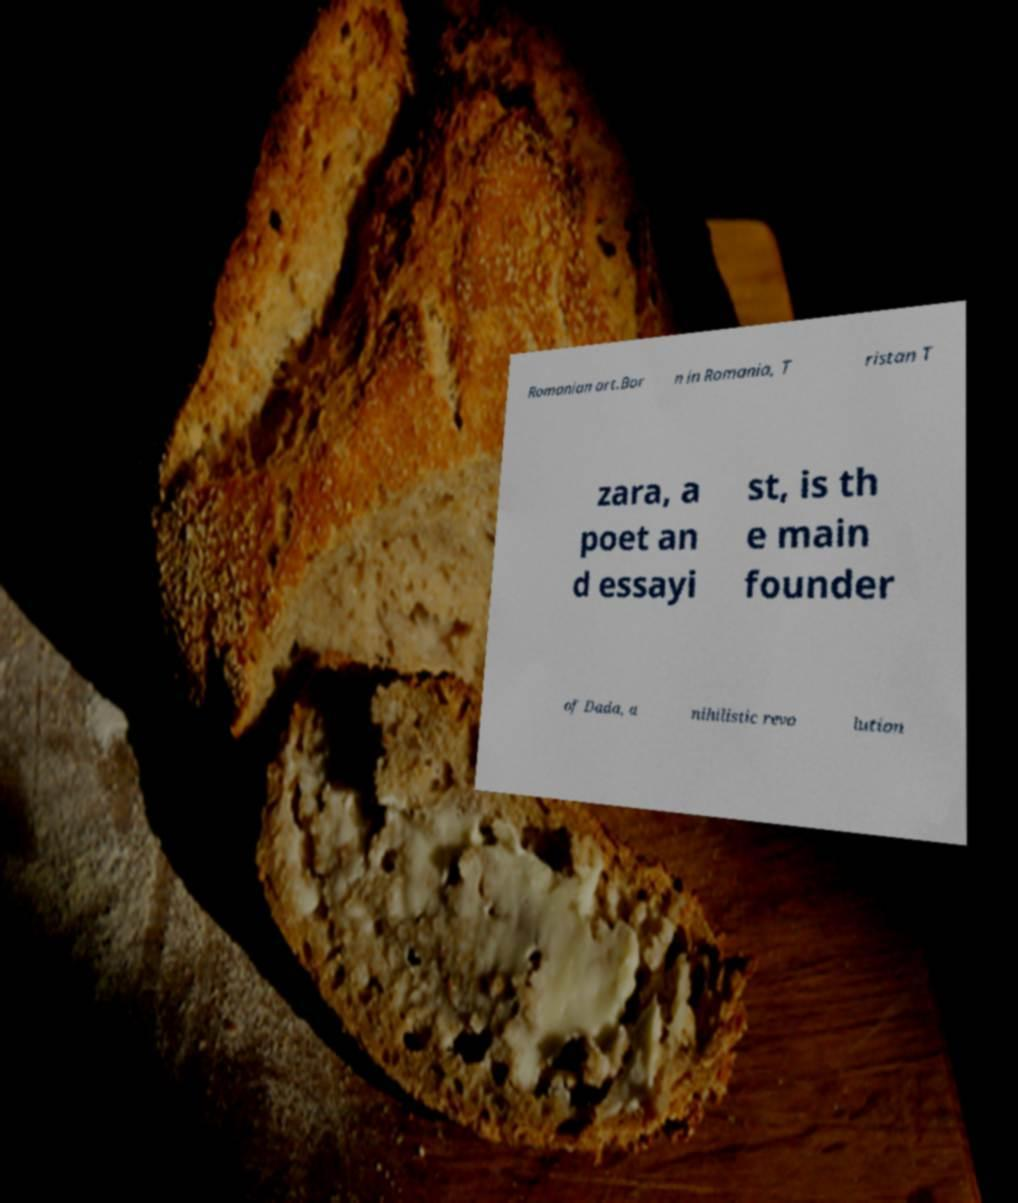For documentation purposes, I need the text within this image transcribed. Could you provide that? Romanian art.Bor n in Romania, T ristan T zara, a poet an d essayi st, is th e main founder of Dada, a nihilistic revo lution 